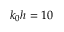<formula> <loc_0><loc_0><loc_500><loc_500>k _ { 0 } h = 1 0</formula> 